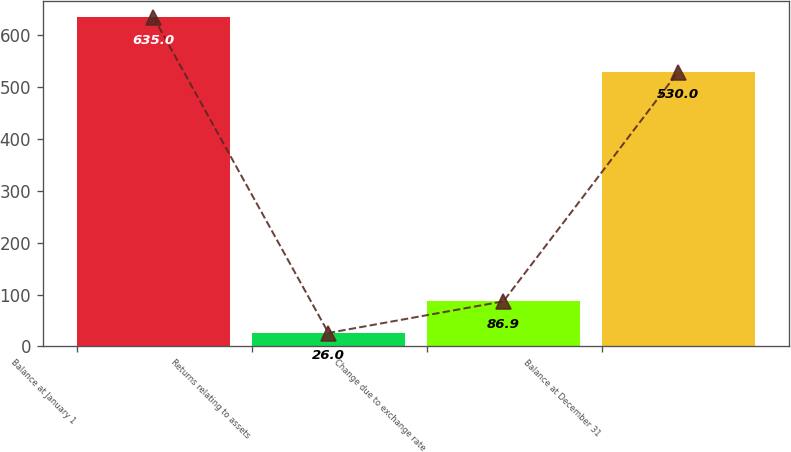Convert chart to OTSL. <chart><loc_0><loc_0><loc_500><loc_500><bar_chart><fcel>Balance at January 1<fcel>Returns relating to assets<fcel>Change due to exchange rate<fcel>Balance at December 31<nl><fcel>635<fcel>26<fcel>86.9<fcel>530<nl></chart> 